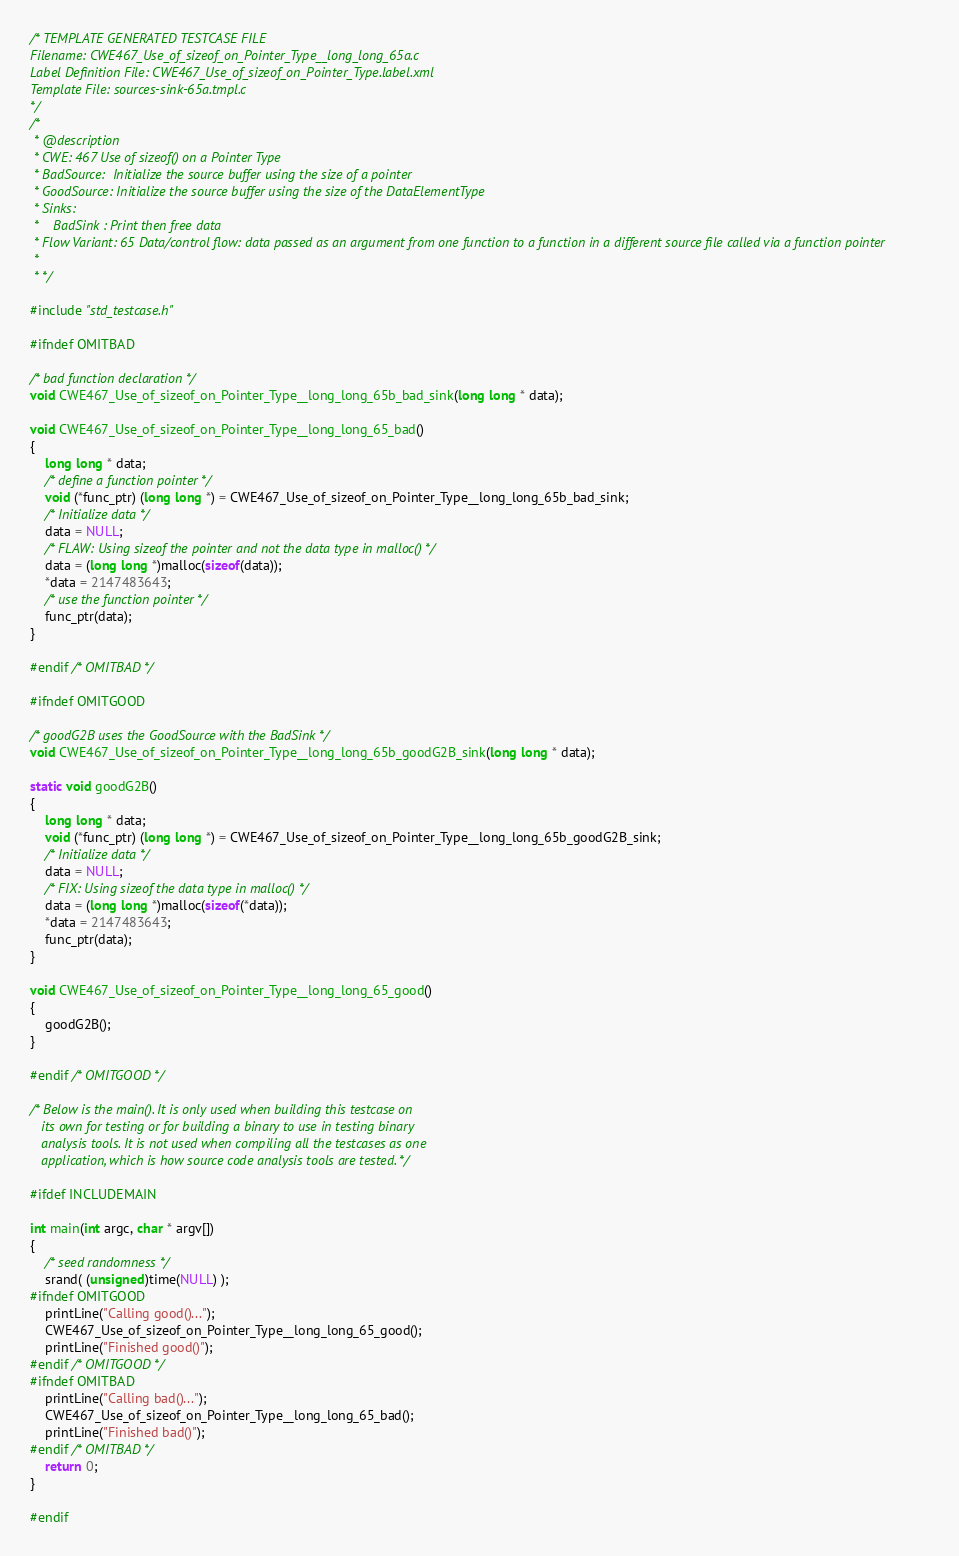<code> <loc_0><loc_0><loc_500><loc_500><_C_>/* TEMPLATE GENERATED TESTCASE FILE
Filename: CWE467_Use_of_sizeof_on_Pointer_Type__long_long_65a.c
Label Definition File: CWE467_Use_of_sizeof_on_Pointer_Type.label.xml
Template File: sources-sink-65a.tmpl.c
*/
/*
 * @description
 * CWE: 467 Use of sizeof() on a Pointer Type
 * BadSource:  Initialize the source buffer using the size of a pointer
 * GoodSource: Initialize the source buffer using the size of the DataElementType
 * Sinks:
 *    BadSink : Print then free data
 * Flow Variant: 65 Data/control flow: data passed as an argument from one function to a function in a different source file called via a function pointer
 *
 * */

#include "std_testcase.h"

#ifndef OMITBAD

/* bad function declaration */
void CWE467_Use_of_sizeof_on_Pointer_Type__long_long_65b_bad_sink(long long * data);

void CWE467_Use_of_sizeof_on_Pointer_Type__long_long_65_bad()
{
    long long * data;
    /* define a function pointer */
    void (*func_ptr) (long long *) = CWE467_Use_of_sizeof_on_Pointer_Type__long_long_65b_bad_sink;
    /* Initialize data */
    data = NULL;
    /* FLAW: Using sizeof the pointer and not the data type in malloc() */
    data = (long long *)malloc(sizeof(data));
    *data = 2147483643;
    /* use the function pointer */
    func_ptr(data);
}

#endif /* OMITBAD */

#ifndef OMITGOOD

/* goodG2B uses the GoodSource with the BadSink */
void CWE467_Use_of_sizeof_on_Pointer_Type__long_long_65b_goodG2B_sink(long long * data);

static void goodG2B()
{
    long long * data;
    void (*func_ptr) (long long *) = CWE467_Use_of_sizeof_on_Pointer_Type__long_long_65b_goodG2B_sink;
    /* Initialize data */
    data = NULL;
    /* FIX: Using sizeof the data type in malloc() */
    data = (long long *)malloc(sizeof(*data));
    *data = 2147483643;
    func_ptr(data);
}

void CWE467_Use_of_sizeof_on_Pointer_Type__long_long_65_good()
{
    goodG2B();
}

#endif /* OMITGOOD */

/* Below is the main(). It is only used when building this testcase on
   its own for testing or for building a binary to use in testing binary
   analysis tools. It is not used when compiling all the testcases as one
   application, which is how source code analysis tools are tested. */

#ifdef INCLUDEMAIN

int main(int argc, char * argv[])
{
    /* seed randomness */
    srand( (unsigned)time(NULL) );
#ifndef OMITGOOD
    printLine("Calling good()...");
    CWE467_Use_of_sizeof_on_Pointer_Type__long_long_65_good();
    printLine("Finished good()");
#endif /* OMITGOOD */
#ifndef OMITBAD
    printLine("Calling bad()...");
    CWE467_Use_of_sizeof_on_Pointer_Type__long_long_65_bad();
    printLine("Finished bad()");
#endif /* OMITBAD */
    return 0;
}

#endif
</code> 